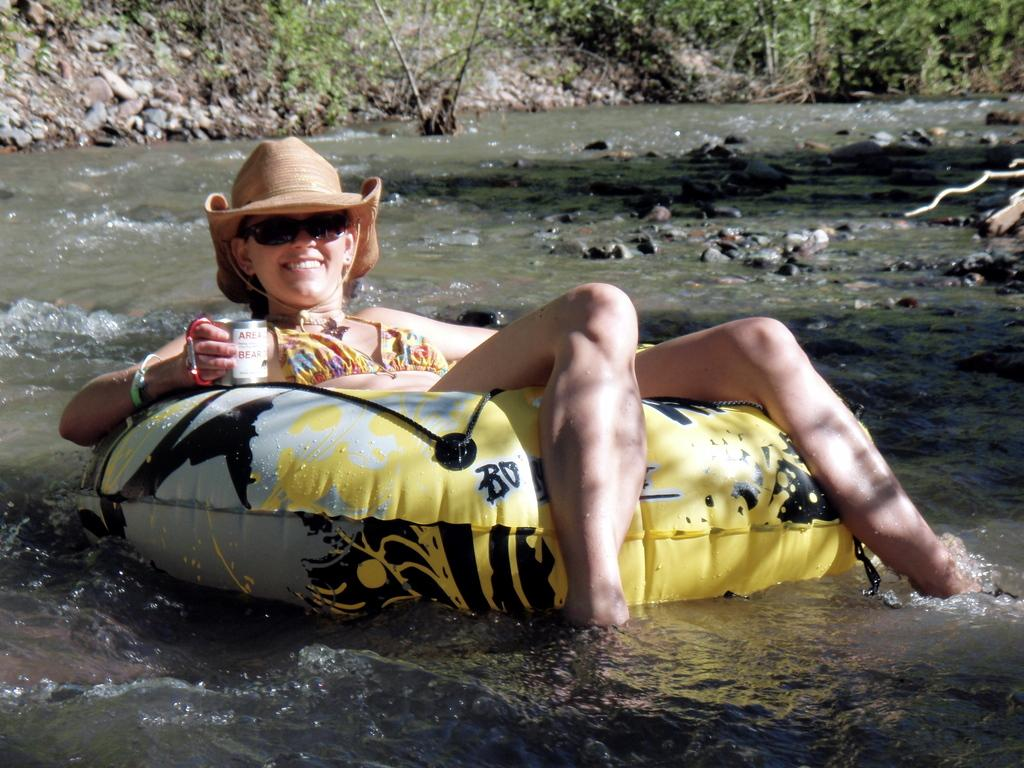What is the person in the image doing? There is a person sitting on a tube in the image. What can be seen in the background of the image? Plants and water are visible in the image. What type of sound can be heard coming from the station in the image? There is no station present in the image, so it's not possible to determine what, if any, sounds might be heard. 